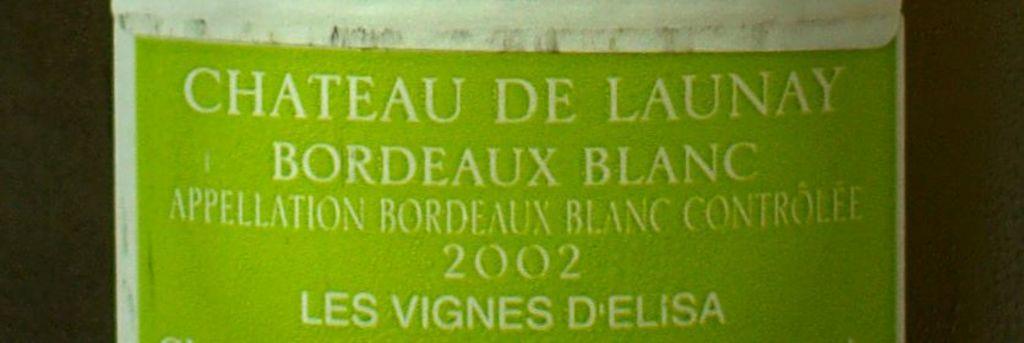What is the year of the wine?
Offer a very short reply. 2002. What wine is this?
Your answer should be very brief. Bordeaux blanc. 